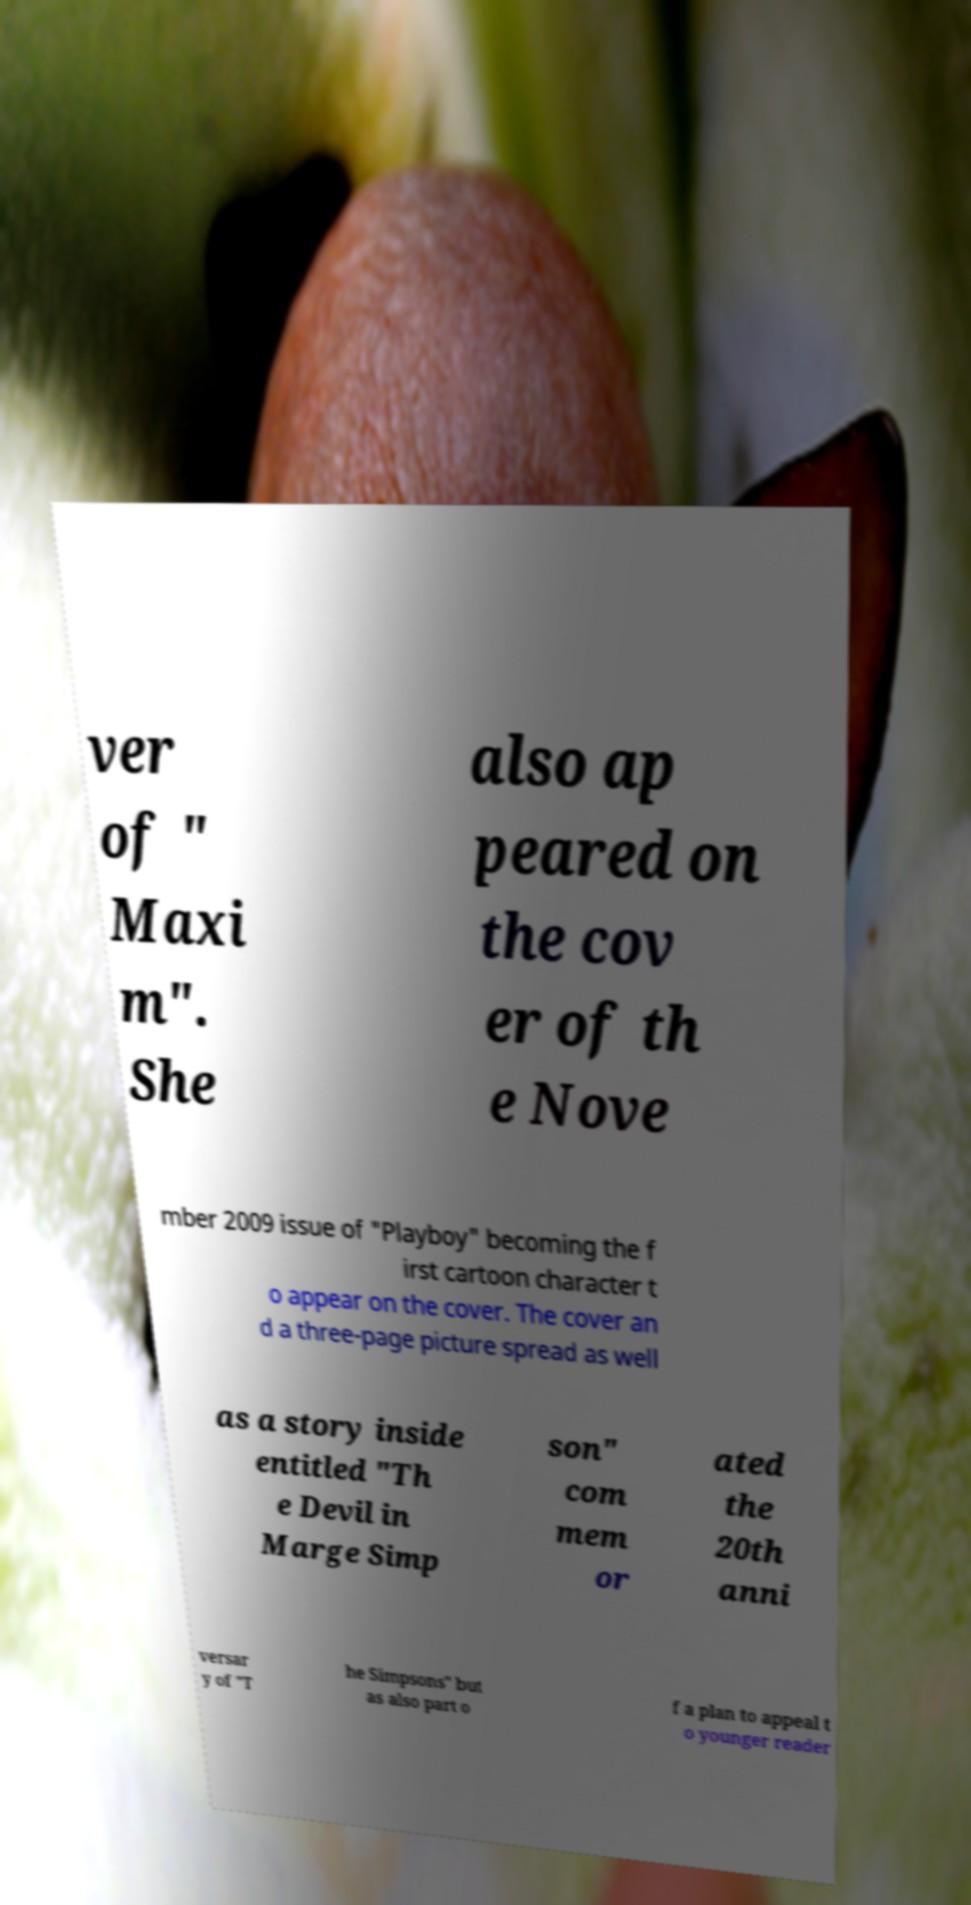There's text embedded in this image that I need extracted. Can you transcribe it verbatim? ver of " Maxi m". She also ap peared on the cov er of th e Nove mber 2009 issue of "Playboy" becoming the f irst cartoon character t o appear on the cover. The cover an d a three-page picture spread as well as a story inside entitled "Th e Devil in Marge Simp son" com mem or ated the 20th anni versar y of "T he Simpsons" but as also part o f a plan to appeal t o younger reader 